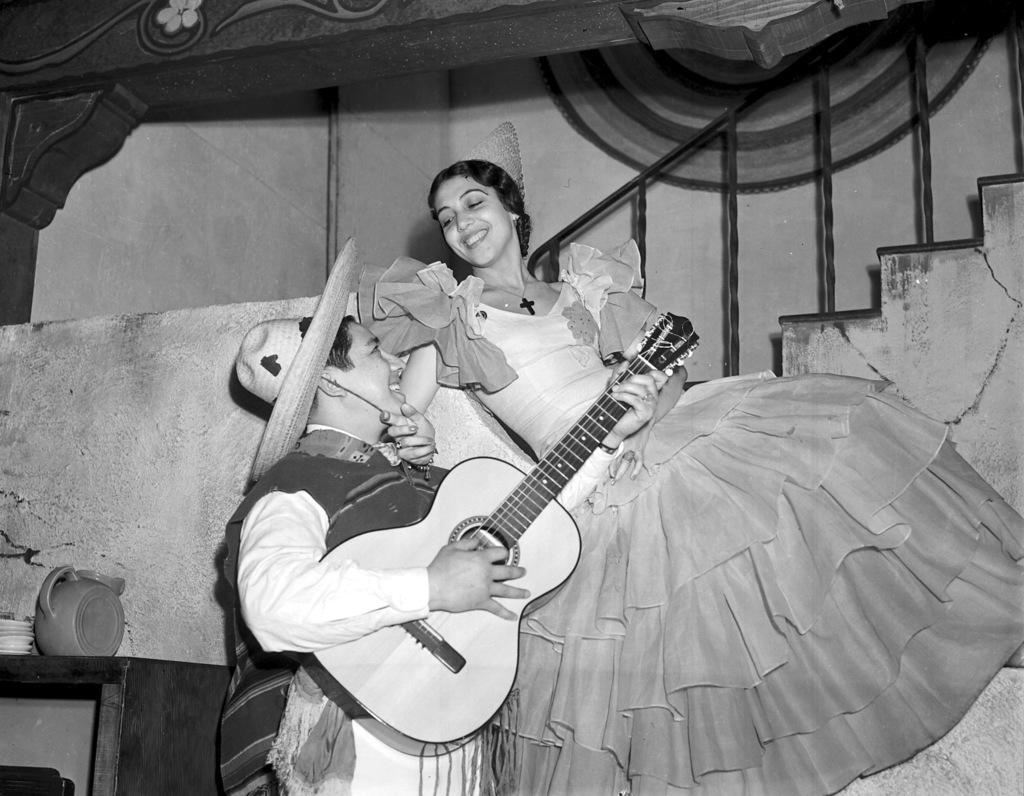Please provide a concise description of this image. In the image we can see there are people who are standing and holding guitar in their hand and the image is in black and white colour. 